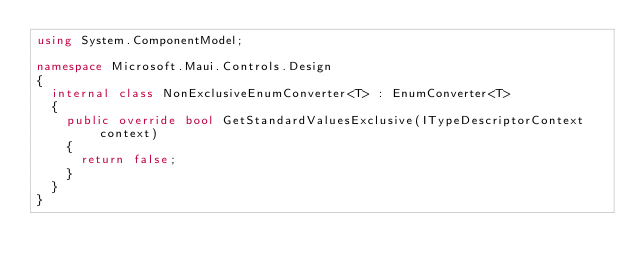Convert code to text. <code><loc_0><loc_0><loc_500><loc_500><_C#_>using System.ComponentModel;

namespace Microsoft.Maui.Controls.Design
{
	internal class NonExclusiveEnumConverter<T> : EnumConverter<T>
	{
		public override bool GetStandardValuesExclusive(ITypeDescriptorContext context)
		{
			return false;
		}
	}
}
</code> 